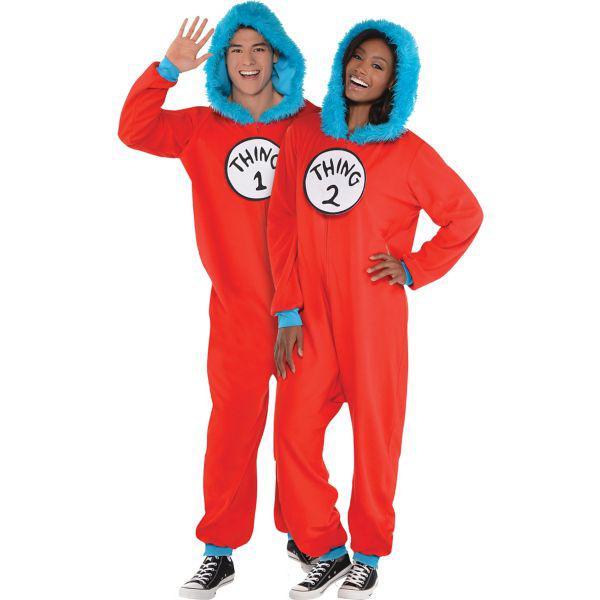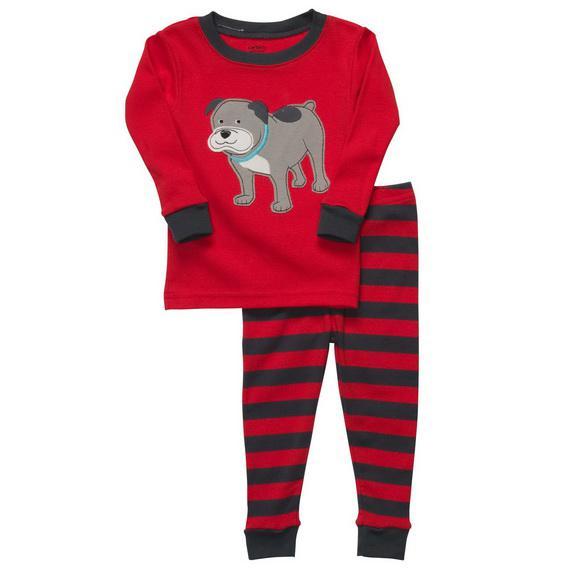The first image is the image on the left, the second image is the image on the right. Given the left and right images, does the statement "At least one image shows red onesie pajamas" hold true? Answer yes or no. Yes. The first image is the image on the left, the second image is the image on the right. For the images displayed, is the sentence "One or more outfits are """"Thing 1 and Thing 2"""" themed." factually correct? Answer yes or no. Yes. 